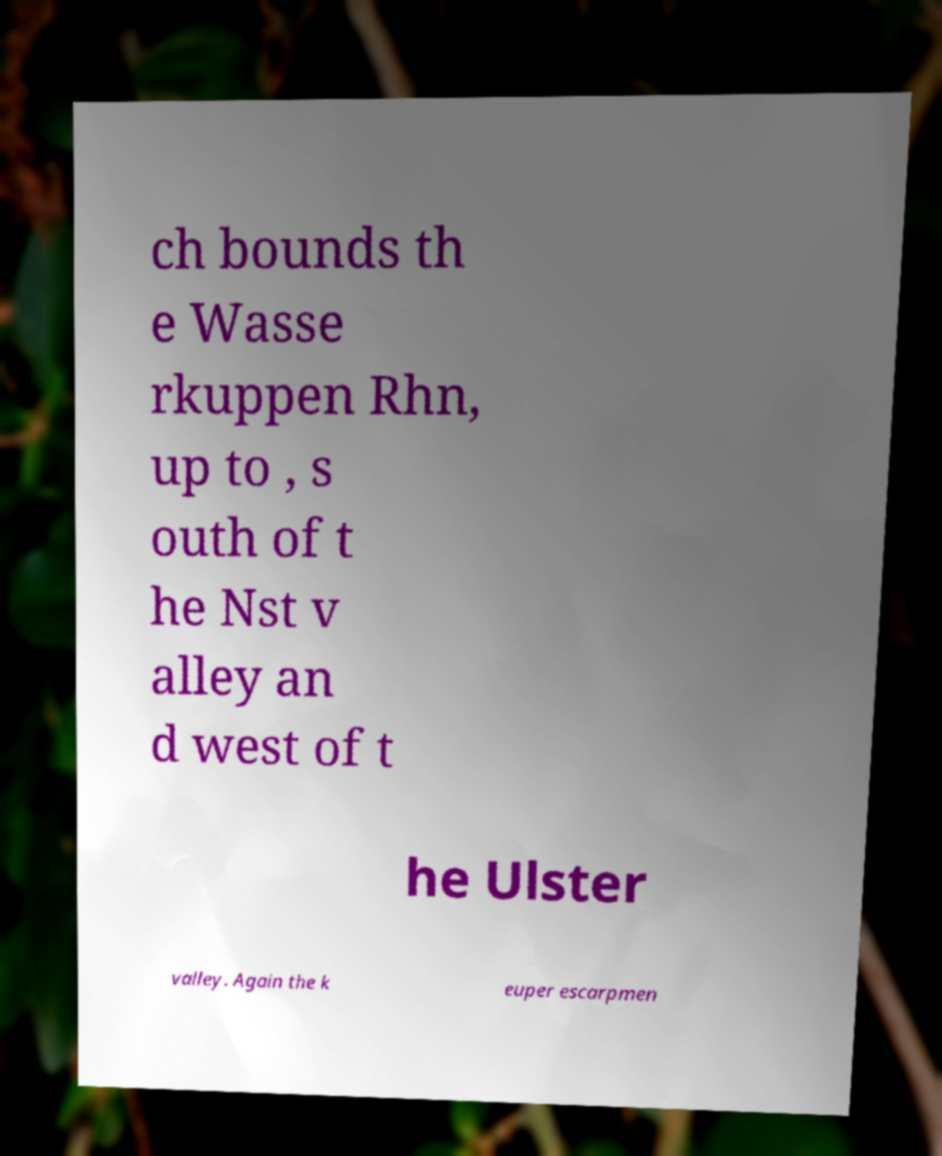Can you read and provide the text displayed in the image?This photo seems to have some interesting text. Can you extract and type it out for me? ch bounds th e Wasse rkuppen Rhn, up to , s outh of t he Nst v alley an d west of t he Ulster valley. Again the k euper escarpmen 